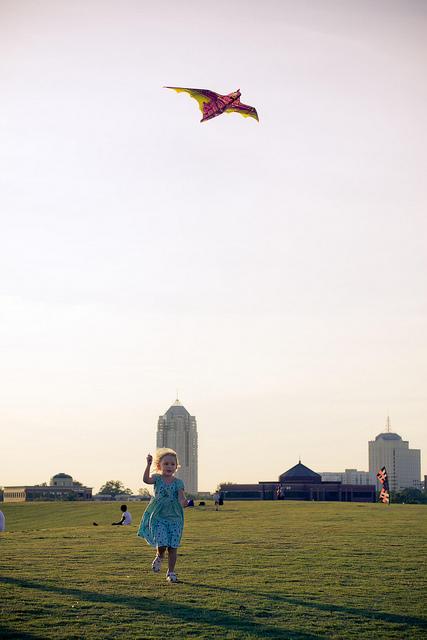What is the child after?
Answer briefly. Kite. What game is being played on the ground?
Concise answer only. Kite flying. What's on the sky?
Answer briefly. Kite. Where is the city?
Short answer required. Background. How many people are in the picture?
Short answer required. 3. How many people are there?
Be succinct. 2. How many kites are there?
Short answer required. 1. Is this surface easy to jog on?
Write a very short answer. Yes. 